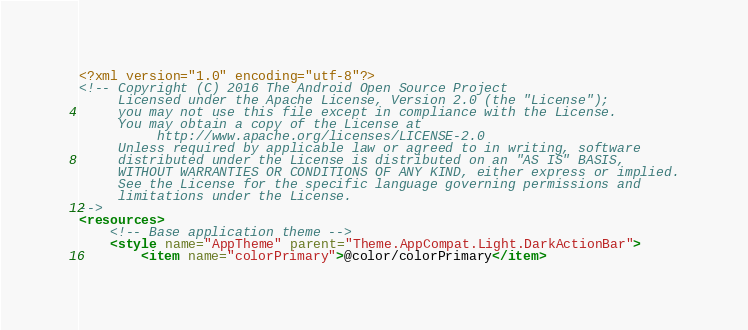Convert code to text. <code><loc_0><loc_0><loc_500><loc_500><_XML_><?xml version="1.0" encoding="utf-8"?>
<!-- Copyright (C) 2016 The Android Open Source Project
     Licensed under the Apache License, Version 2.0 (the "License");
     you may not use this file except in compliance with the License.
     You may obtain a copy of the License at
          http://www.apache.org/licenses/LICENSE-2.0
     Unless required by applicable law or agreed to in writing, software
     distributed under the License is distributed on an "AS IS" BASIS,
     WITHOUT WARRANTIES OR CONDITIONS OF ANY KIND, either express or implied.
     See the License for the specific language governing permissions and
     limitations under the License.
-->
<resources>
    <!-- Base application theme -->
    <style name="AppTheme" parent="Theme.AppCompat.Light.DarkActionBar">
        <item name="colorPrimary">@color/colorPrimary</item></code> 